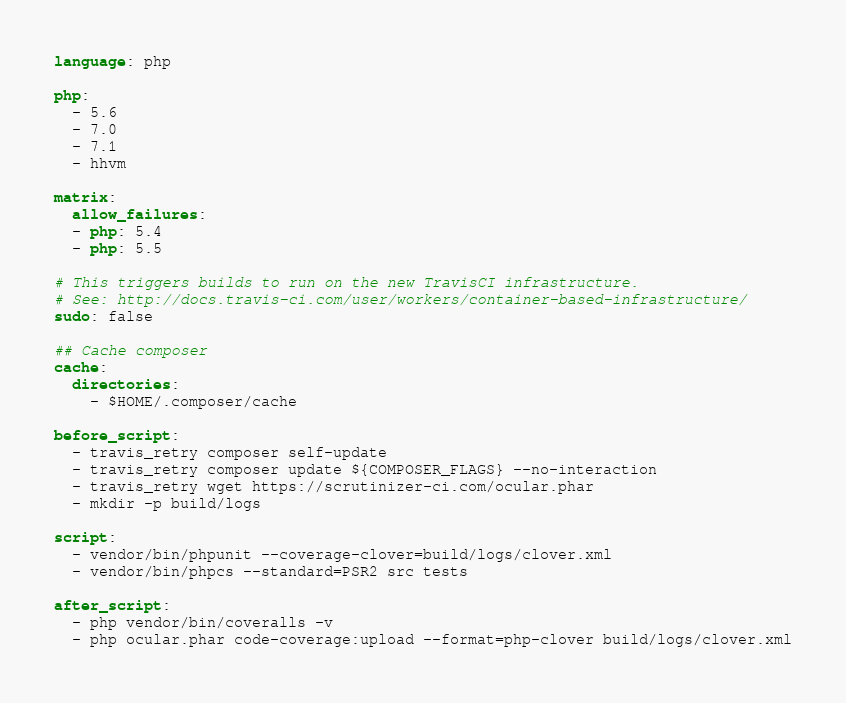<code> <loc_0><loc_0><loc_500><loc_500><_YAML_>language: php

php:
  - 5.6
  - 7.0
  - 7.1
  - hhvm

matrix:
  allow_failures:
  - php: 5.4
  - php: 5.5

# This triggers builds to run on the new TravisCI infrastructure.
# See: http://docs.travis-ci.com/user/workers/container-based-infrastructure/
sudo: false

## Cache composer
cache:
  directories:
    - $HOME/.composer/cache

before_script:
  - travis_retry composer self-update
  - travis_retry composer update ${COMPOSER_FLAGS} --no-interaction
  - travis_retry wget https://scrutinizer-ci.com/ocular.phar
  - mkdir -p build/logs

script:
  - vendor/bin/phpunit --coverage-clover=build/logs/clover.xml
  - vendor/bin/phpcs --standard=PSR2 src tests

after_script:
  - php vendor/bin/coveralls -v
  - php ocular.phar code-coverage:upload --format=php-clover build/logs/clover.xml</code> 